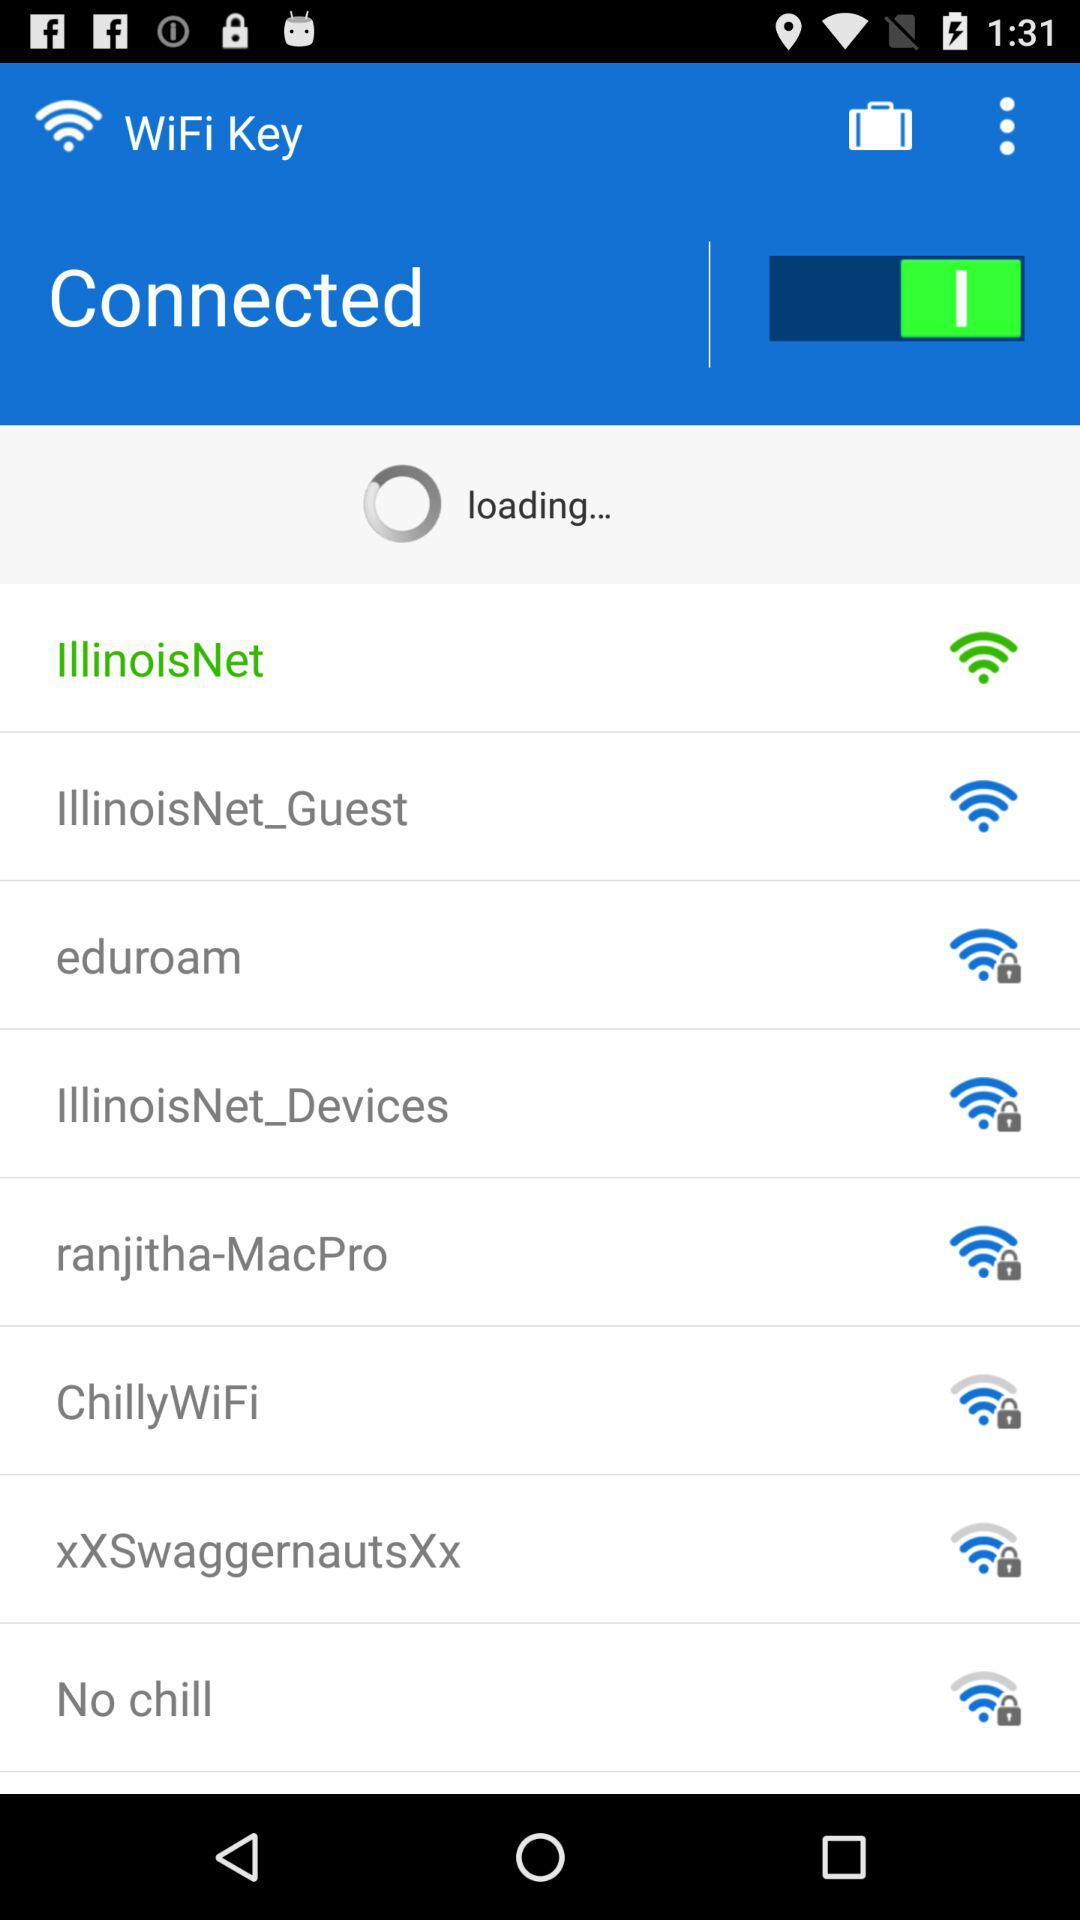Which WiFi networks are locked? WiFi networks that are locked are "eduroam", "IllinoisNet_Devices", "ranjitha-MacPro", "ChillyWiFi", "xXSwaggernautsXx" and "No chill". 